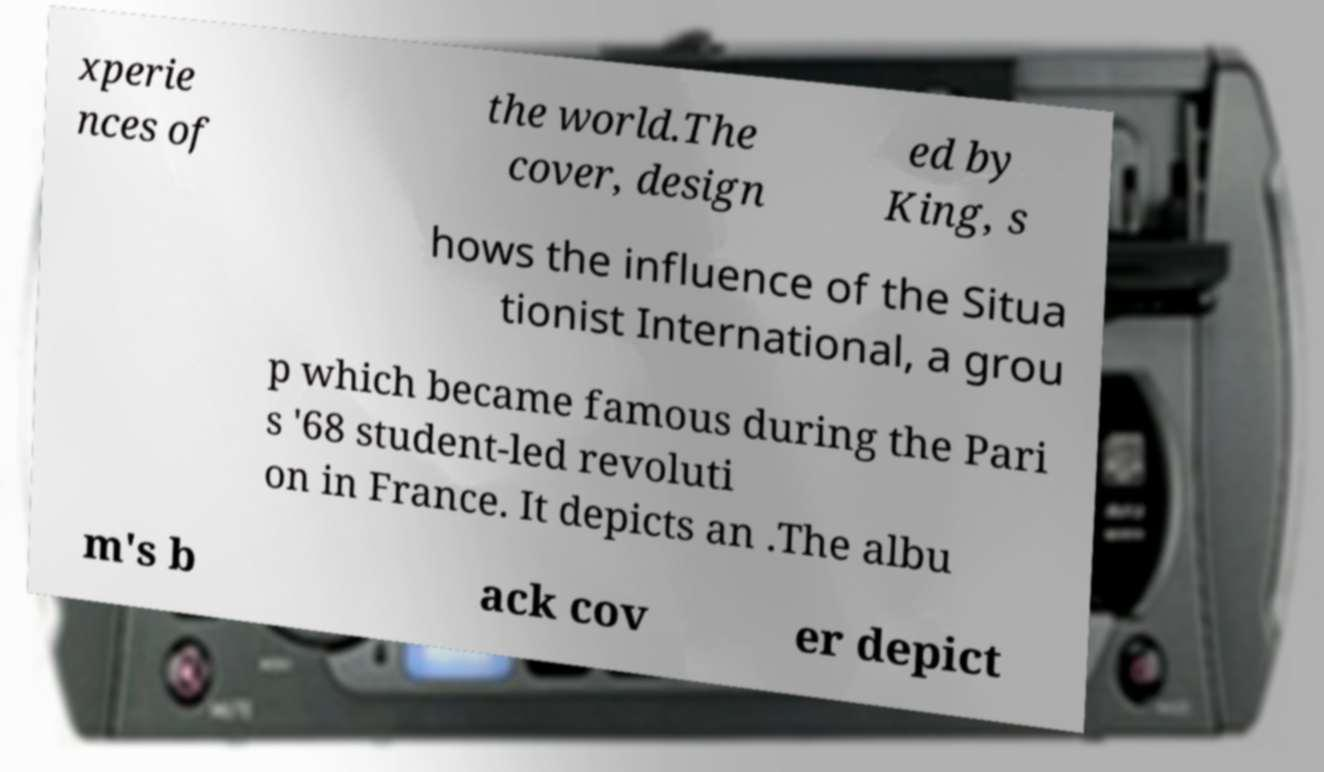There's text embedded in this image that I need extracted. Can you transcribe it verbatim? xperie nces of the world.The cover, design ed by King, s hows the influence of the Situa tionist International, a grou p which became famous during the Pari s '68 student-led revoluti on in France. It depicts an .The albu m's b ack cov er depict 